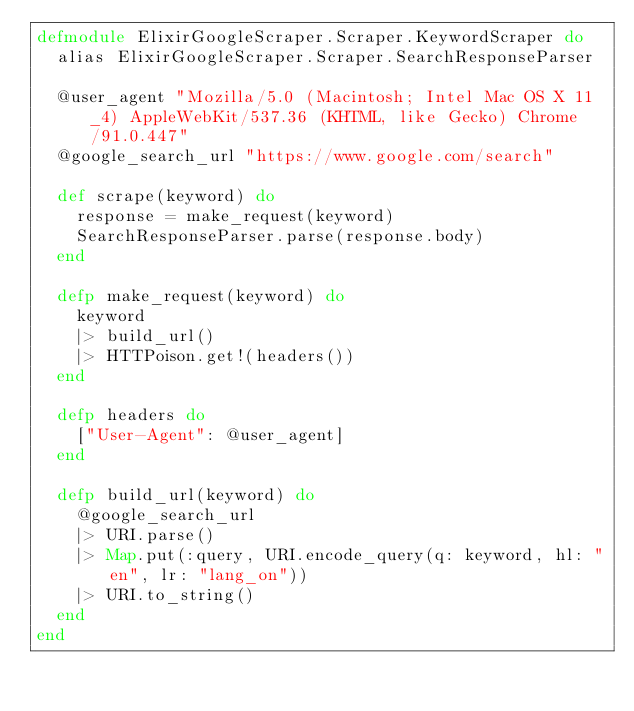<code> <loc_0><loc_0><loc_500><loc_500><_Elixir_>defmodule ElixirGoogleScraper.Scraper.KeywordScraper do
  alias ElixirGoogleScraper.Scraper.SearchResponseParser

  @user_agent "Mozilla/5.0 (Macintosh; Intel Mac OS X 11_4) AppleWebKit/537.36 (KHTML, like Gecko) Chrome/91.0.447"
  @google_search_url "https://www.google.com/search"

  def scrape(keyword) do
    response = make_request(keyword)
    SearchResponseParser.parse(response.body)
  end

  defp make_request(keyword) do
    keyword
    |> build_url()
    |> HTTPoison.get!(headers())
  end

  defp headers do
    ["User-Agent": @user_agent]
  end

  defp build_url(keyword) do
    @google_search_url
    |> URI.parse()
    |> Map.put(:query, URI.encode_query(q: keyword, hl: "en", lr: "lang_on"))
    |> URI.to_string()
  end
end
</code> 